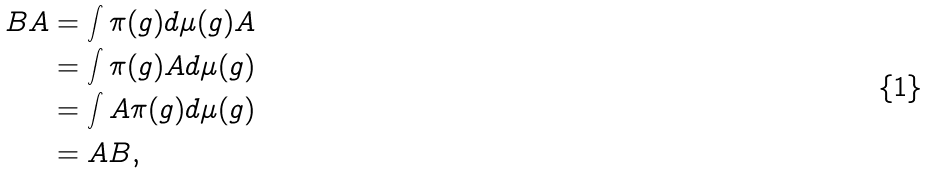Convert formula to latex. <formula><loc_0><loc_0><loc_500><loc_500>B A & = \int \pi ( g ) d \mu ( g ) A \\ & = \int \pi ( g ) A d \mu ( g ) \\ & = \int A \pi ( g ) d \mu ( g ) \\ & = A B ,</formula> 